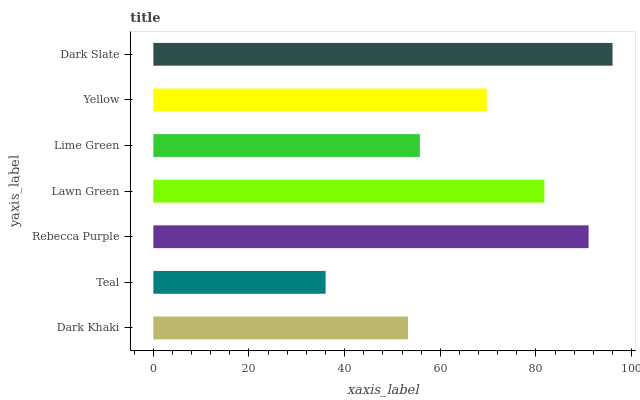Is Teal the minimum?
Answer yes or no. Yes. Is Dark Slate the maximum?
Answer yes or no. Yes. Is Rebecca Purple the minimum?
Answer yes or no. No. Is Rebecca Purple the maximum?
Answer yes or no. No. Is Rebecca Purple greater than Teal?
Answer yes or no. Yes. Is Teal less than Rebecca Purple?
Answer yes or no. Yes. Is Teal greater than Rebecca Purple?
Answer yes or no. No. Is Rebecca Purple less than Teal?
Answer yes or no. No. Is Yellow the high median?
Answer yes or no. Yes. Is Yellow the low median?
Answer yes or no. Yes. Is Lime Green the high median?
Answer yes or no. No. Is Lawn Green the low median?
Answer yes or no. No. 